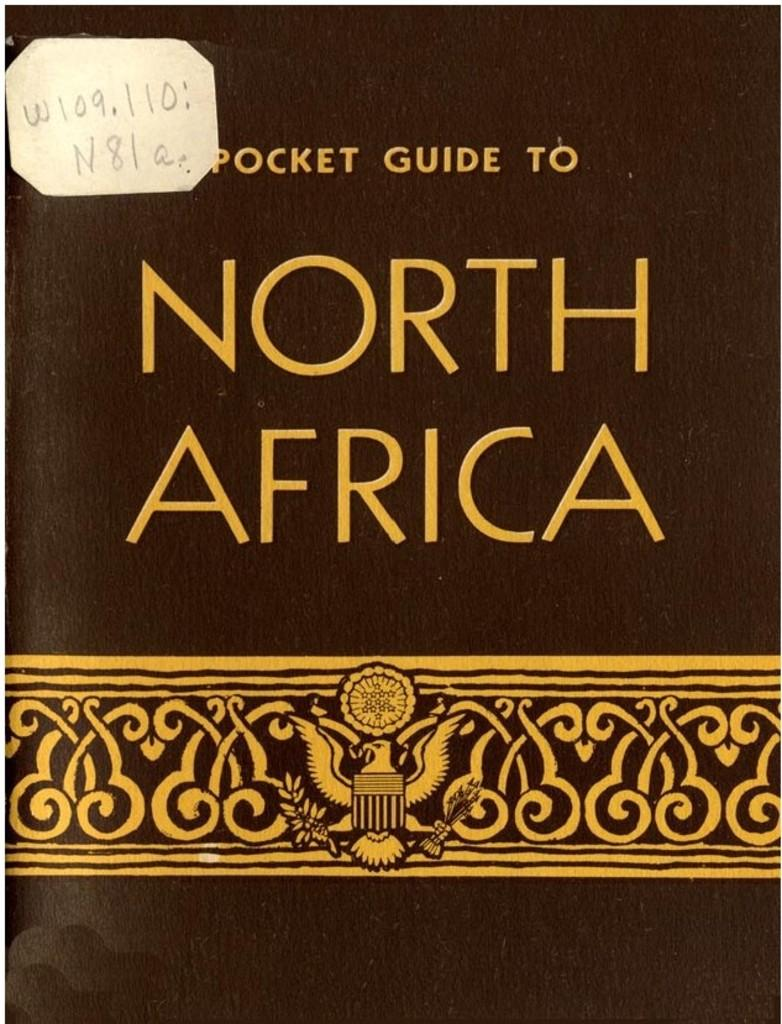<image>
Provide a brief description of the given image. A Pocket Guide to North Africa has an insignia with an eagle below the title. 